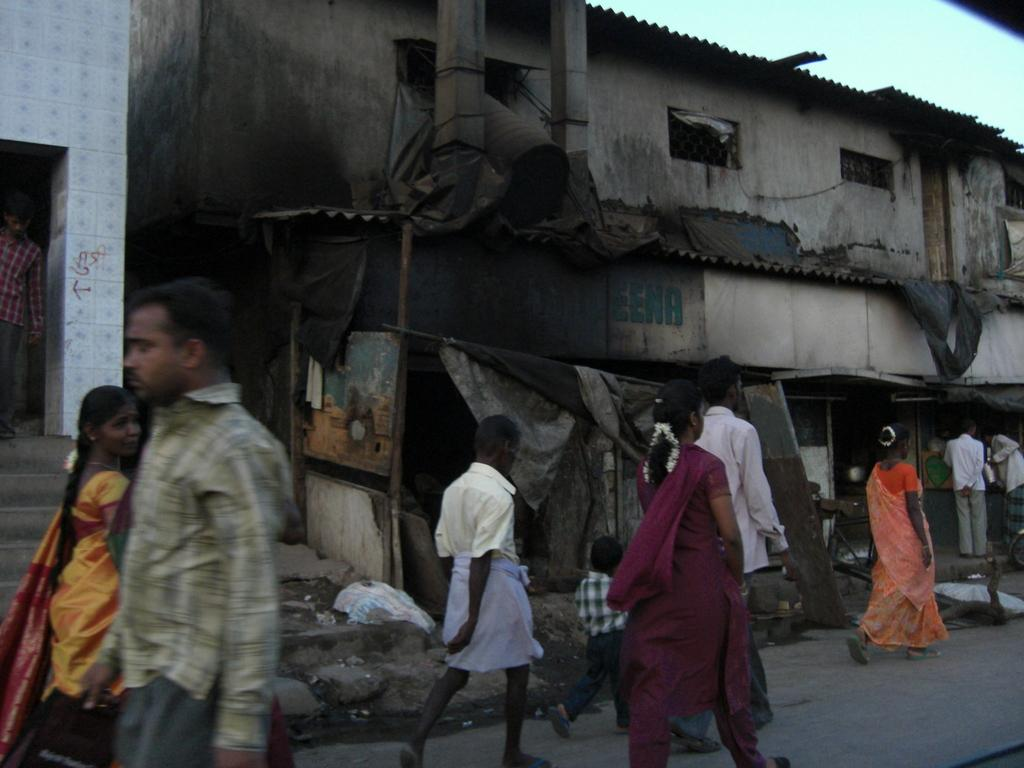How many people are in the image? There are people in the image, but the exact number is not specified. What is one person holding in the image? One person is holding a bag in the image. What can be seen on the board in the image? There is a board with text in the image. What is visible in the background of the image? The sky is visible in the image. What type of scarf is being ordered by the person in the image? There is no mention of a scarf or any ordering activity in the image. 